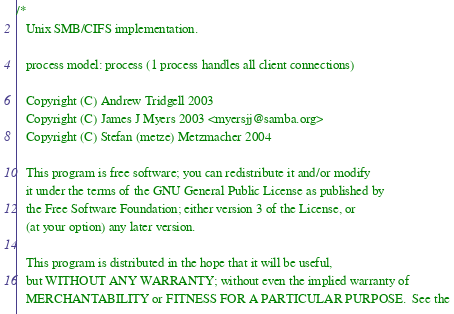<code> <loc_0><loc_0><loc_500><loc_500><_C_>/* 
   Unix SMB/CIFS implementation.

   process model: process (1 process handles all client connections)

   Copyright (C) Andrew Tridgell 2003
   Copyright (C) James J Myers 2003 <myersjj@samba.org>
   Copyright (C) Stefan (metze) Metzmacher 2004
   
   This program is free software; you can redistribute it and/or modify
   it under the terms of the GNU General Public License as published by
   the Free Software Foundation; either version 3 of the License, or
   (at your option) any later version.
   
   This program is distributed in the hope that it will be useful,
   but WITHOUT ANY WARRANTY; without even the implied warranty of
   MERCHANTABILITY or FITNESS FOR A PARTICULAR PURPOSE.  See the</code> 